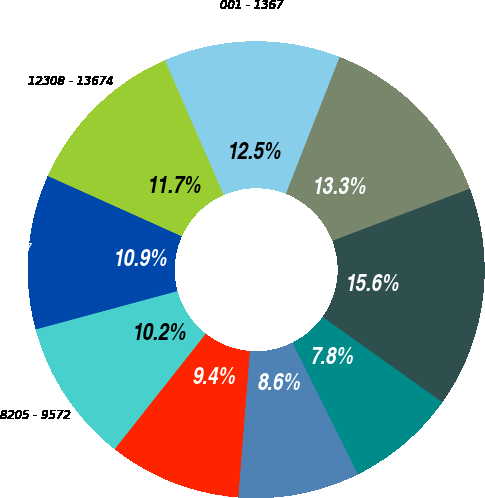<chart> <loc_0><loc_0><loc_500><loc_500><pie_chart><fcel>001 - 1367<fcel>1368 - 2735<fcel>2736 - 4102<fcel>4103 - 5470<fcel>5471 - 6837<fcel>6838 - 8204<fcel>8205 - 9572<fcel>9573 - 12307<fcel>12308 - 13674<nl><fcel>12.5%<fcel>13.28%<fcel>15.62%<fcel>7.81%<fcel>8.59%<fcel>9.38%<fcel>10.16%<fcel>10.94%<fcel>11.72%<nl></chart> 